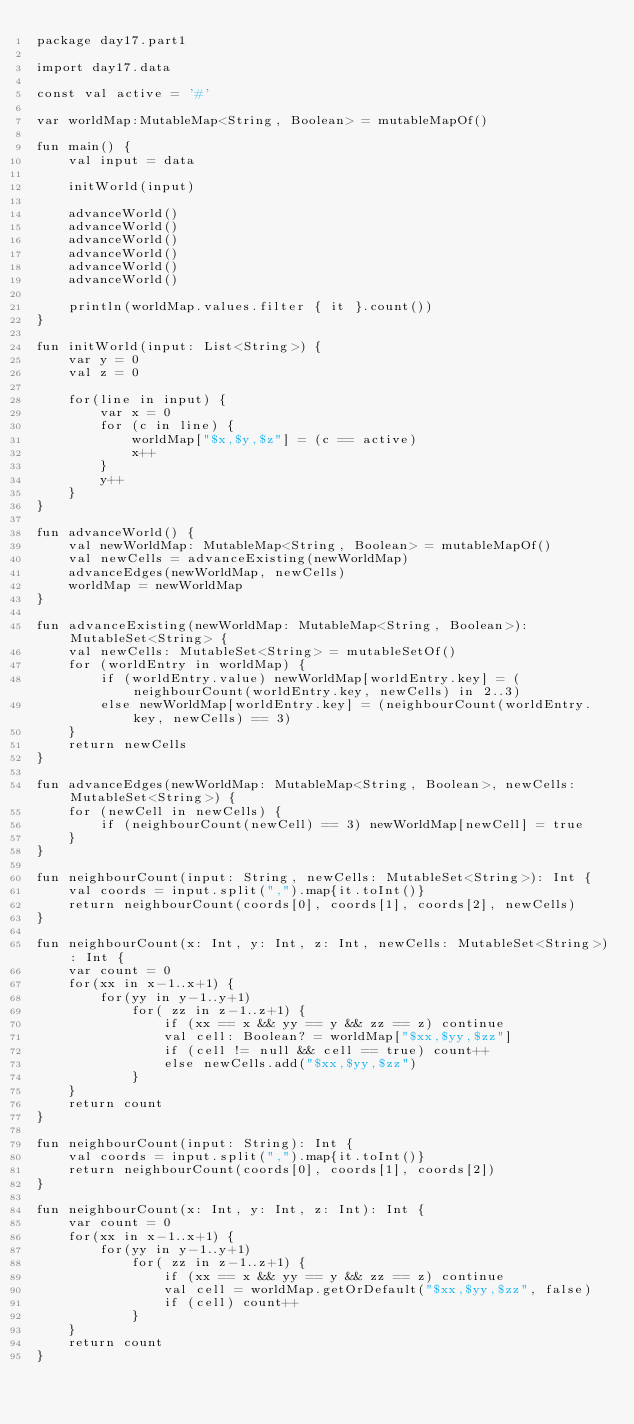<code> <loc_0><loc_0><loc_500><loc_500><_Kotlin_>package day17.part1

import day17.data

const val active = '#'

var worldMap:MutableMap<String, Boolean> = mutableMapOf()

fun main() {
    val input = data

    initWorld(input)

    advanceWorld()
    advanceWorld()
    advanceWorld()
    advanceWorld()
    advanceWorld()
    advanceWorld()

    println(worldMap.values.filter { it }.count())
}

fun initWorld(input: List<String>) {
    var y = 0
    val z = 0

    for(line in input) {
        var x = 0
        for (c in line) {
            worldMap["$x,$y,$z"] = (c == active)
            x++
        }
        y++
    }
}

fun advanceWorld() {
    val newWorldMap: MutableMap<String, Boolean> = mutableMapOf()
    val newCells = advanceExisting(newWorldMap)
    advanceEdges(newWorldMap, newCells)
    worldMap = newWorldMap
}

fun advanceExisting(newWorldMap: MutableMap<String, Boolean>): MutableSet<String> {
    val newCells: MutableSet<String> = mutableSetOf()
    for (worldEntry in worldMap) {
        if (worldEntry.value) newWorldMap[worldEntry.key] = (neighbourCount(worldEntry.key, newCells) in 2..3)
        else newWorldMap[worldEntry.key] = (neighbourCount(worldEntry.key, newCells) == 3)
    }
    return newCells
}

fun advanceEdges(newWorldMap: MutableMap<String, Boolean>, newCells: MutableSet<String>) {
    for (newCell in newCells) {
        if (neighbourCount(newCell) == 3) newWorldMap[newCell] = true
    }
}

fun neighbourCount(input: String, newCells: MutableSet<String>): Int {
    val coords = input.split(",").map{it.toInt()}
    return neighbourCount(coords[0], coords[1], coords[2], newCells)
}

fun neighbourCount(x: Int, y: Int, z: Int, newCells: MutableSet<String>): Int {
    var count = 0
    for(xx in x-1..x+1) {
        for(yy in y-1..y+1)
            for( zz in z-1..z+1) {
                if (xx == x && yy == y && zz == z) continue
                val cell: Boolean? = worldMap["$xx,$yy,$zz"]
                if (cell != null && cell == true) count++
                else newCells.add("$xx,$yy,$zz")
            }
    }
    return count
}

fun neighbourCount(input: String): Int {
    val coords = input.split(",").map{it.toInt()}
    return neighbourCount(coords[0], coords[1], coords[2])
}

fun neighbourCount(x: Int, y: Int, z: Int): Int {
    var count = 0
    for(xx in x-1..x+1) {
        for(yy in y-1..y+1)
            for( zz in z-1..z+1) {
                if (xx == x && yy == y && zz == z) continue
                val cell = worldMap.getOrDefault("$xx,$yy,$zz", false)
                if (cell) count++
            }
    }
    return count
}</code> 